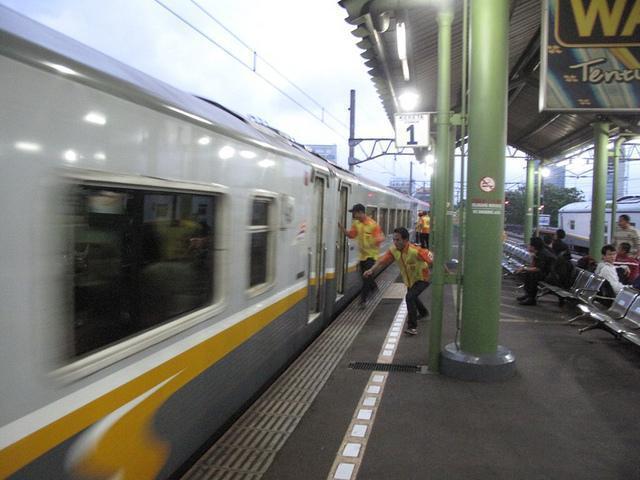How many trains can you see?
Give a very brief answer. 2. How many benches are visible?
Give a very brief answer. 1. How many people are there?
Give a very brief answer. 1. 